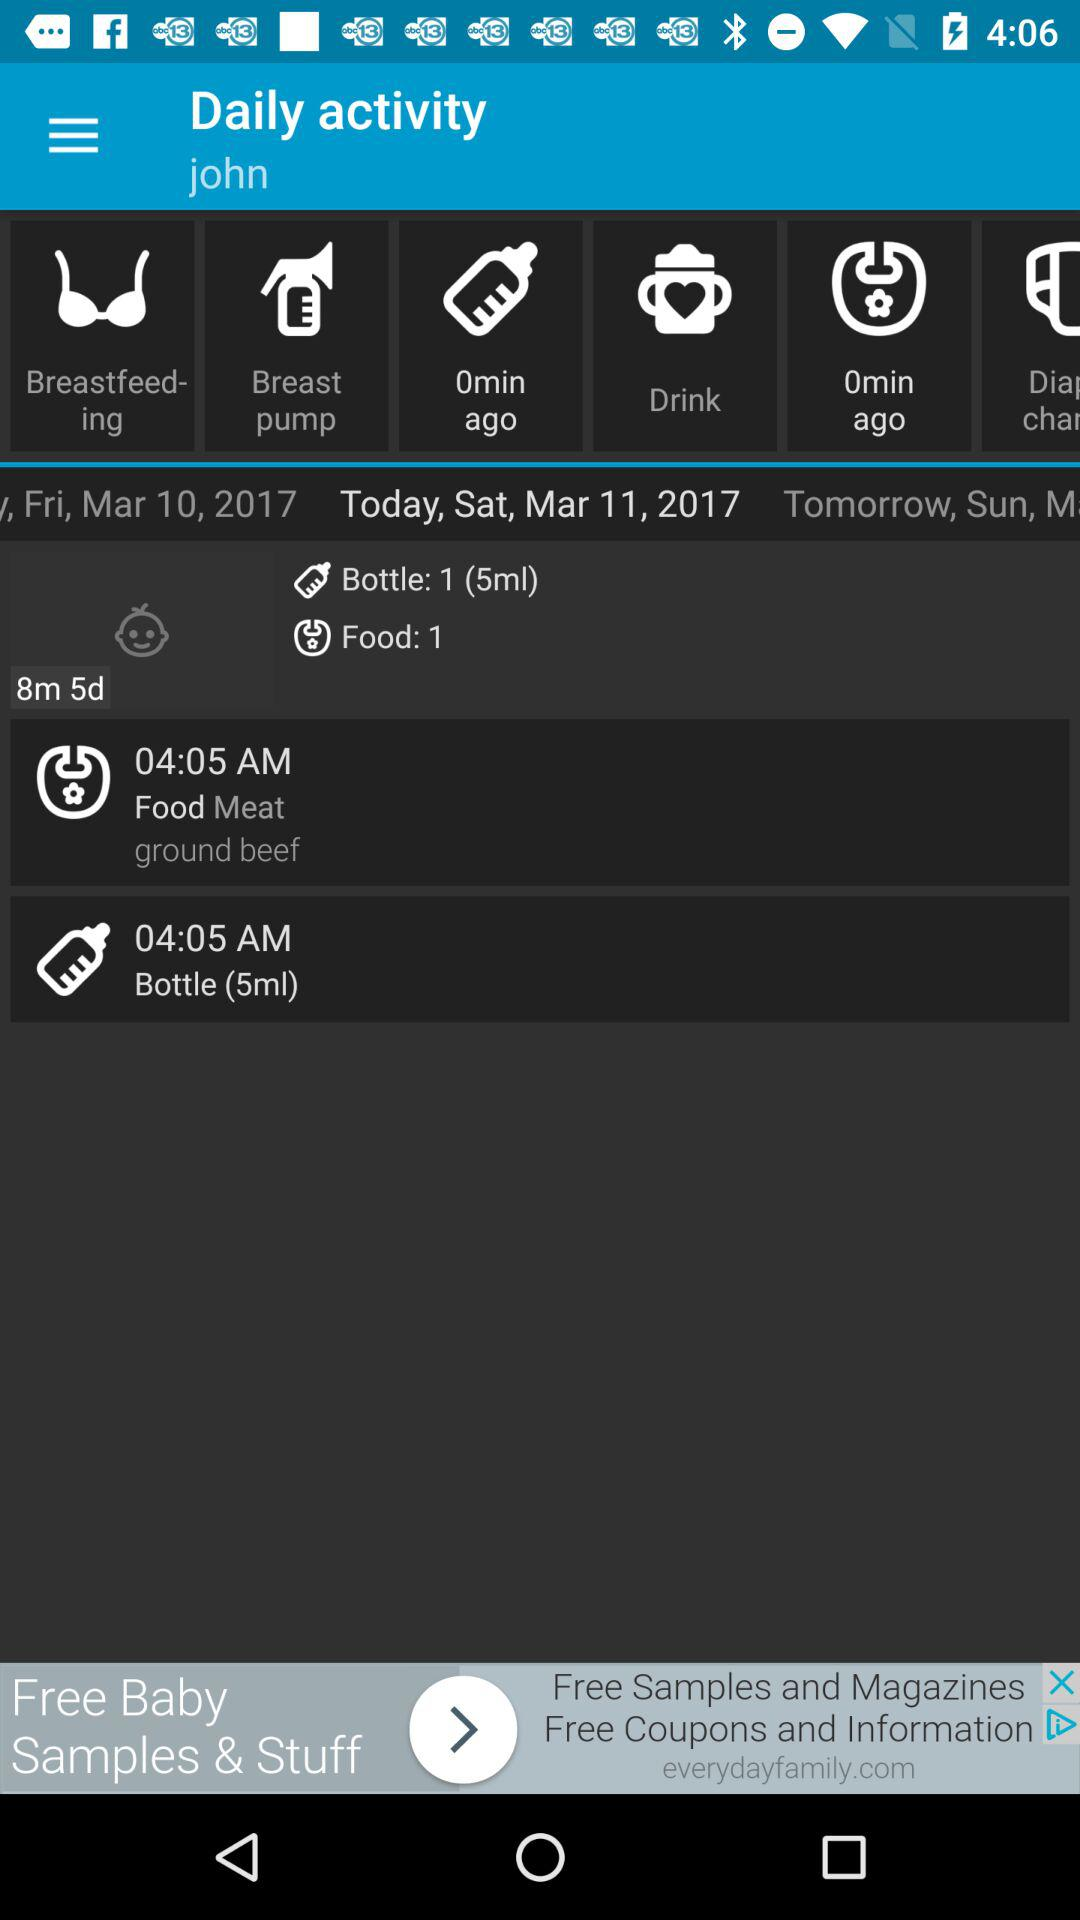What is the name of the user? The name of the user is John. 